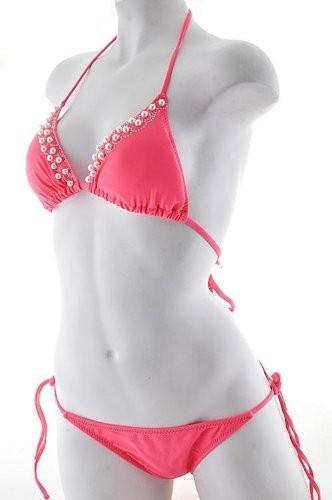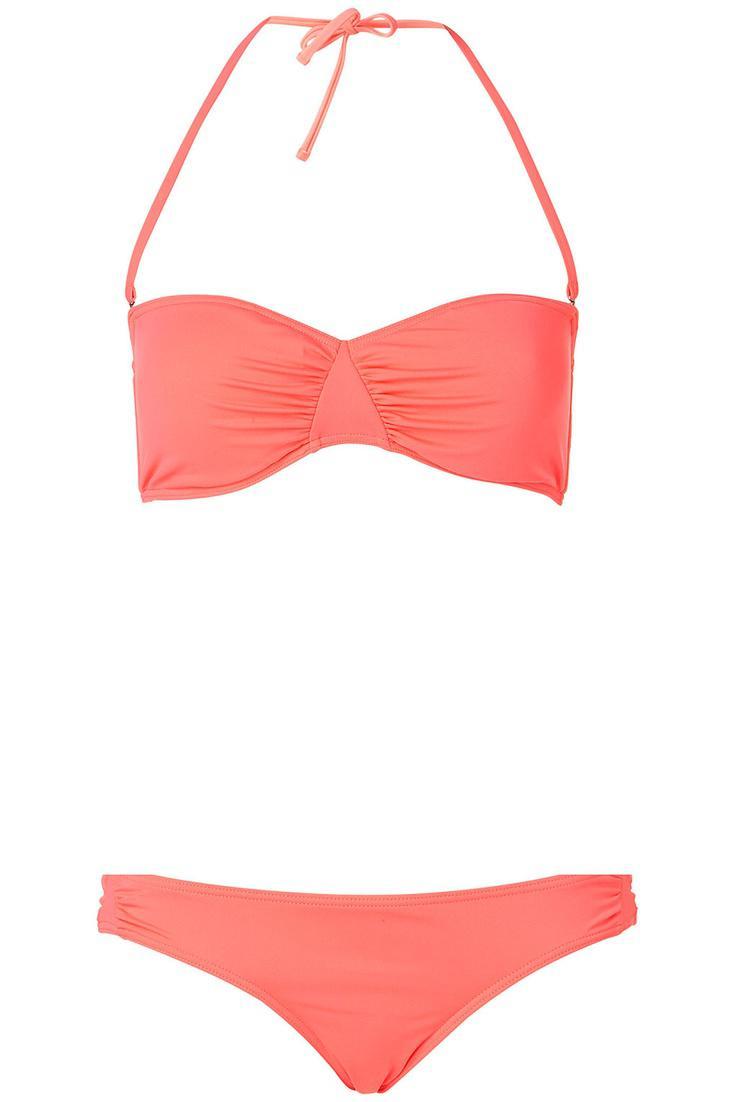The first image is the image on the left, the second image is the image on the right. For the images displayed, is the sentence "There is not less than one mannequin" factually correct? Answer yes or no. Yes. 